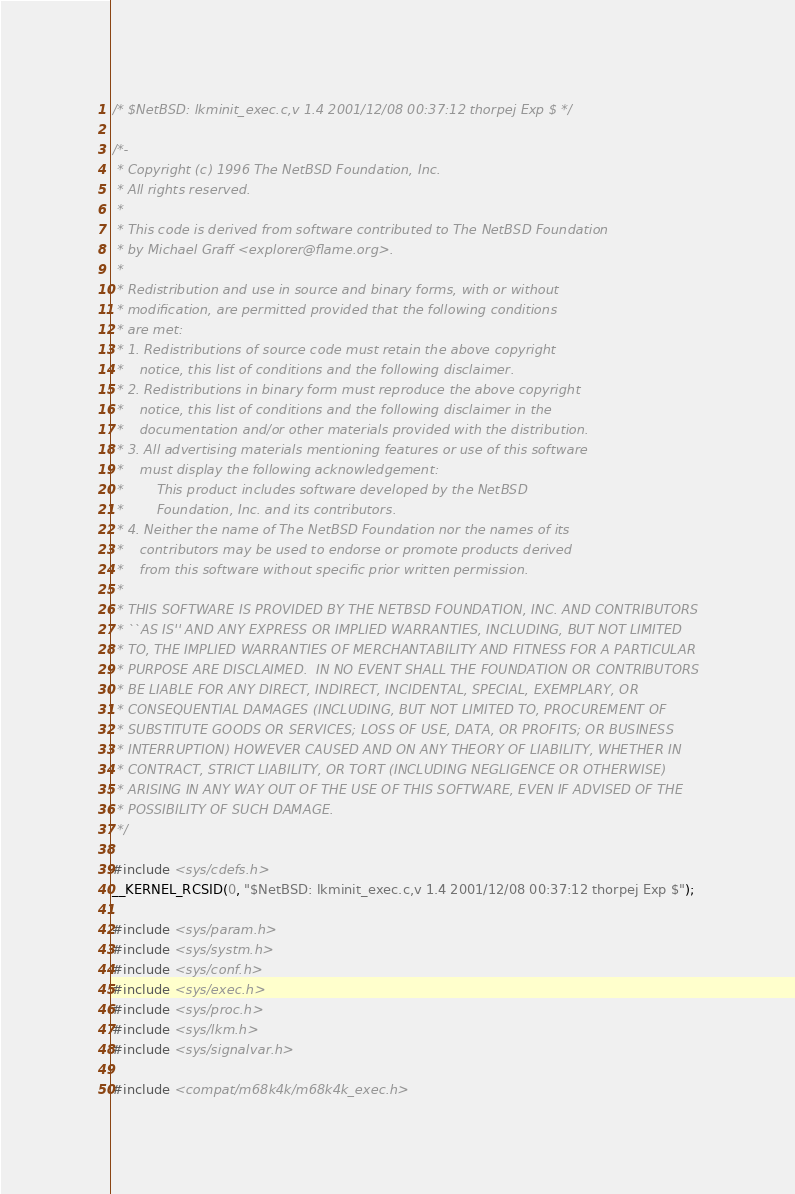<code> <loc_0><loc_0><loc_500><loc_500><_C_>/* $NetBSD: lkminit_exec.c,v 1.4 2001/12/08 00:37:12 thorpej Exp $ */

/*-
 * Copyright (c) 1996 The NetBSD Foundation, Inc.
 * All rights reserved.
 *
 * This code is derived from software contributed to The NetBSD Foundation
 * by Michael Graff <explorer@flame.org>.
 *
 * Redistribution and use in source and binary forms, with or without
 * modification, are permitted provided that the following conditions
 * are met:
 * 1. Redistributions of source code must retain the above copyright
 *    notice, this list of conditions and the following disclaimer.
 * 2. Redistributions in binary form must reproduce the above copyright
 *    notice, this list of conditions and the following disclaimer in the
 *    documentation and/or other materials provided with the distribution.
 * 3. All advertising materials mentioning features or use of this software
 *    must display the following acknowledgement:
 *        This product includes software developed by the NetBSD
 *        Foundation, Inc. and its contributors.
 * 4. Neither the name of The NetBSD Foundation nor the names of its
 *    contributors may be used to endorse or promote products derived
 *    from this software without specific prior written permission.
 *
 * THIS SOFTWARE IS PROVIDED BY THE NETBSD FOUNDATION, INC. AND CONTRIBUTORS
 * ``AS IS'' AND ANY EXPRESS OR IMPLIED WARRANTIES, INCLUDING, BUT NOT LIMITED
 * TO, THE IMPLIED WARRANTIES OF MERCHANTABILITY AND FITNESS FOR A PARTICULAR
 * PURPOSE ARE DISCLAIMED.  IN NO EVENT SHALL THE FOUNDATION OR CONTRIBUTORS
 * BE LIABLE FOR ANY DIRECT, INDIRECT, INCIDENTAL, SPECIAL, EXEMPLARY, OR
 * CONSEQUENTIAL DAMAGES (INCLUDING, BUT NOT LIMITED TO, PROCUREMENT OF
 * SUBSTITUTE GOODS OR SERVICES; LOSS OF USE, DATA, OR PROFITS; OR BUSINESS
 * INTERRUPTION) HOWEVER CAUSED AND ON ANY THEORY OF LIABILITY, WHETHER IN
 * CONTRACT, STRICT LIABILITY, OR TORT (INCLUDING NEGLIGENCE OR OTHERWISE)
 * ARISING IN ANY WAY OUT OF THE USE OF THIS SOFTWARE, EVEN IF ADVISED OF THE
 * POSSIBILITY OF SUCH DAMAGE.
 */

#include <sys/cdefs.h>
__KERNEL_RCSID(0, "$NetBSD: lkminit_exec.c,v 1.4 2001/12/08 00:37:12 thorpej Exp $");

#include <sys/param.h>
#include <sys/systm.h>
#include <sys/conf.h>
#include <sys/exec.h>
#include <sys/proc.h>
#include <sys/lkm.h>
#include <sys/signalvar.h>

#include <compat/m68k4k/m68k4k_exec.h>
</code> 